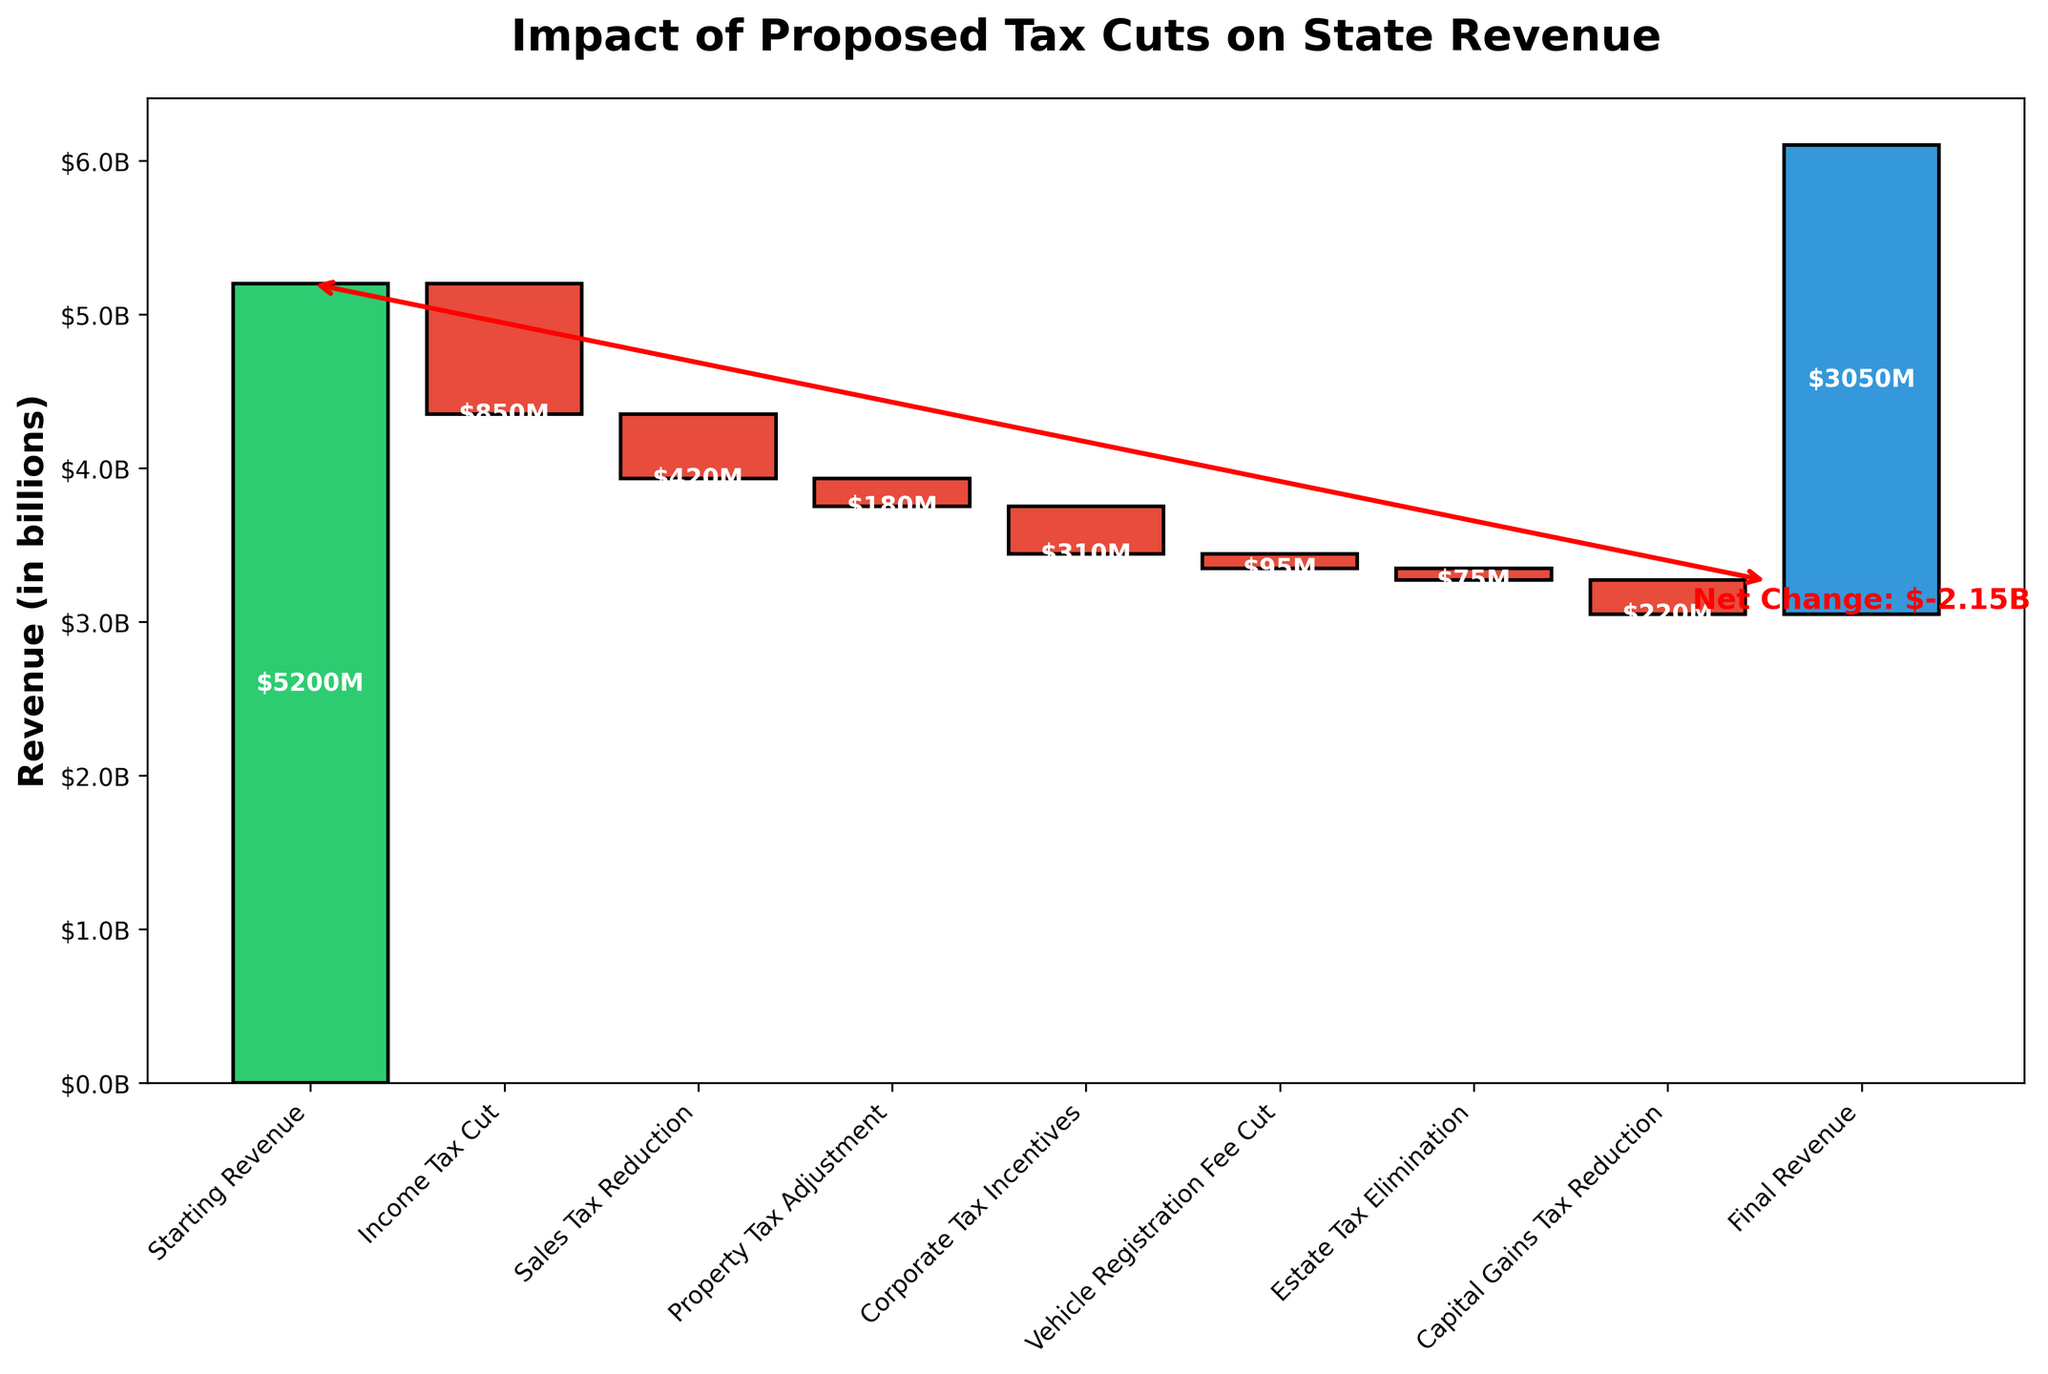What is the title of the chart? The title is typically found at the top of the chart. It provides an overview of what the chart is about.
Answer: Impact of Proposed Tax Cuts on State Revenue What is the initial revenue before any tax cuts? The initial revenue is represented by the first bar in the waterfall chart labeled "Starting Revenue".
Answer: \$5.2 billion By how much does the income tax cut reduce the revenue? The reduction due to income tax cut is shown as the first red bar after the starting revenue.
Answer: \$850 million Which tax cut has the smallest financial impact on the state revenue? By comparing the height of the negative bars, the smallest bar indicating the smallest impact can be identified.
Answer: Estate Tax Elimination (\$75 million) How much is the final revenue after all proposed tax cuts? The final revenue is represented by the last bar labeled "Final Revenue".
Answer: \$3.05 billion What is the net change in revenue due to all proposed tax cuts? The net change can be calculated by subtracting the final revenue bar from the initial revenue bar. It is also annotated in the chart.
Answer: -\$2.15 billion What is the combined impact of the sales tax reduction and the property tax adjustment? The combined impact is found by summing the values of the sales tax reduction and property tax adjustment.
Answer: -\$600 million Which tax cut reduces the revenue more, corporate tax incentives or capital gains tax reduction? By comparing the height of the respective bars, we can determine which cut is larger.
Answer: Corporate Tax Incentives (\$310 million) reduces more than Capital Gains Tax Reduction (\$220 million) How many reductions are shown in the chart? The number of red bars after the starting revenue and before the final revenue represents the number of reductions.
Answer: 7 What is the total reduction in revenue excluding the income tax cut? Sum the values of all reductions except the income tax cut.
Answer: \$1.3 billion 